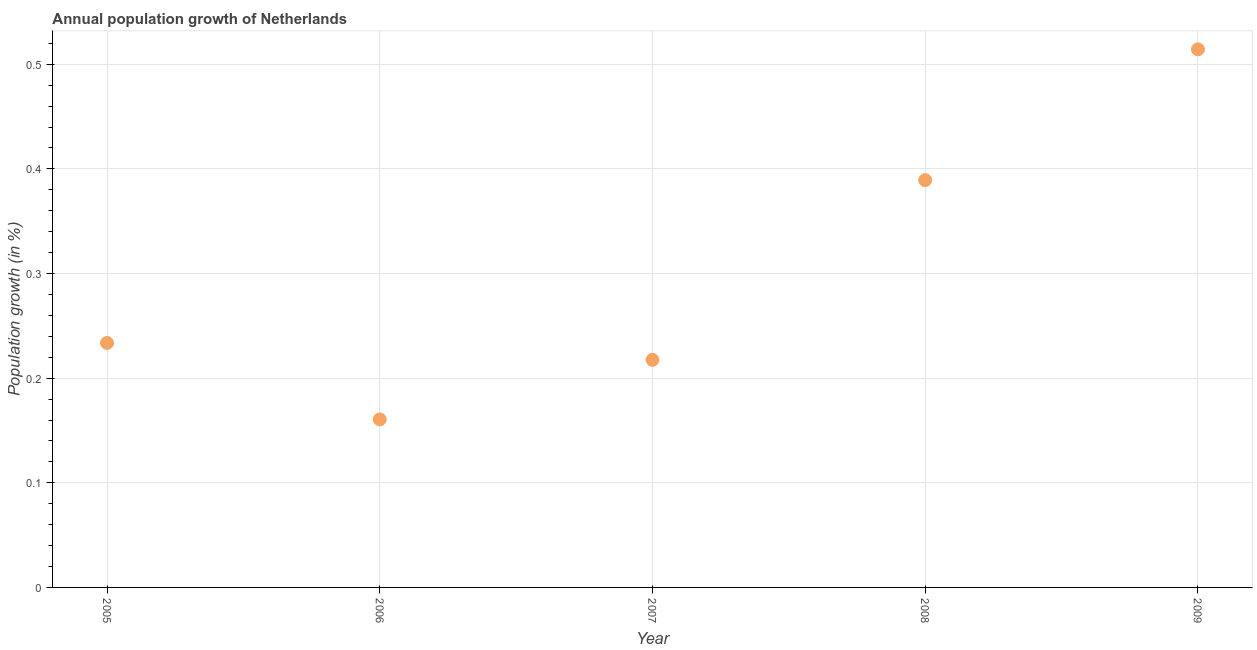What is the population growth in 2007?
Your answer should be compact. 0.22. Across all years, what is the maximum population growth?
Give a very brief answer. 0.51. Across all years, what is the minimum population growth?
Ensure brevity in your answer.  0.16. In which year was the population growth maximum?
Give a very brief answer. 2009. What is the sum of the population growth?
Your response must be concise. 1.52. What is the difference between the population growth in 2005 and 2007?
Your response must be concise. 0.02. What is the average population growth per year?
Your response must be concise. 0.3. What is the median population growth?
Provide a short and direct response. 0.23. In how many years, is the population growth greater than 0.38000000000000006 %?
Offer a terse response. 2. What is the ratio of the population growth in 2006 to that in 2008?
Give a very brief answer. 0.41. What is the difference between the highest and the second highest population growth?
Your answer should be compact. 0.12. Is the sum of the population growth in 2005 and 2009 greater than the maximum population growth across all years?
Make the answer very short. Yes. What is the difference between the highest and the lowest population growth?
Your answer should be very brief. 0.35. In how many years, is the population growth greater than the average population growth taken over all years?
Make the answer very short. 2. How many dotlines are there?
Provide a succinct answer. 1. How many years are there in the graph?
Your response must be concise. 5. What is the difference between two consecutive major ticks on the Y-axis?
Your answer should be very brief. 0.1. Does the graph contain any zero values?
Provide a short and direct response. No. Does the graph contain grids?
Provide a short and direct response. Yes. What is the title of the graph?
Your answer should be compact. Annual population growth of Netherlands. What is the label or title of the X-axis?
Offer a very short reply. Year. What is the label or title of the Y-axis?
Your answer should be compact. Population growth (in %). What is the Population growth (in %) in 2005?
Your response must be concise. 0.23. What is the Population growth (in %) in 2006?
Provide a succinct answer. 0.16. What is the Population growth (in %) in 2007?
Keep it short and to the point. 0.22. What is the Population growth (in %) in 2008?
Your answer should be very brief. 0.39. What is the Population growth (in %) in 2009?
Provide a succinct answer. 0.51. What is the difference between the Population growth (in %) in 2005 and 2006?
Your response must be concise. 0.07. What is the difference between the Population growth (in %) in 2005 and 2007?
Provide a short and direct response. 0.02. What is the difference between the Population growth (in %) in 2005 and 2008?
Offer a very short reply. -0.16. What is the difference between the Population growth (in %) in 2005 and 2009?
Your answer should be compact. -0.28. What is the difference between the Population growth (in %) in 2006 and 2007?
Make the answer very short. -0.06. What is the difference between the Population growth (in %) in 2006 and 2008?
Offer a terse response. -0.23. What is the difference between the Population growth (in %) in 2006 and 2009?
Ensure brevity in your answer.  -0.35. What is the difference between the Population growth (in %) in 2007 and 2008?
Provide a short and direct response. -0.17. What is the difference between the Population growth (in %) in 2007 and 2009?
Your response must be concise. -0.3. What is the difference between the Population growth (in %) in 2008 and 2009?
Make the answer very short. -0.12. What is the ratio of the Population growth (in %) in 2005 to that in 2006?
Provide a short and direct response. 1.46. What is the ratio of the Population growth (in %) in 2005 to that in 2007?
Keep it short and to the point. 1.07. What is the ratio of the Population growth (in %) in 2005 to that in 2009?
Give a very brief answer. 0.45. What is the ratio of the Population growth (in %) in 2006 to that in 2007?
Your answer should be very brief. 0.74. What is the ratio of the Population growth (in %) in 2006 to that in 2008?
Make the answer very short. 0.41. What is the ratio of the Population growth (in %) in 2006 to that in 2009?
Keep it short and to the point. 0.31. What is the ratio of the Population growth (in %) in 2007 to that in 2008?
Provide a succinct answer. 0.56. What is the ratio of the Population growth (in %) in 2007 to that in 2009?
Give a very brief answer. 0.42. What is the ratio of the Population growth (in %) in 2008 to that in 2009?
Your answer should be compact. 0.76. 